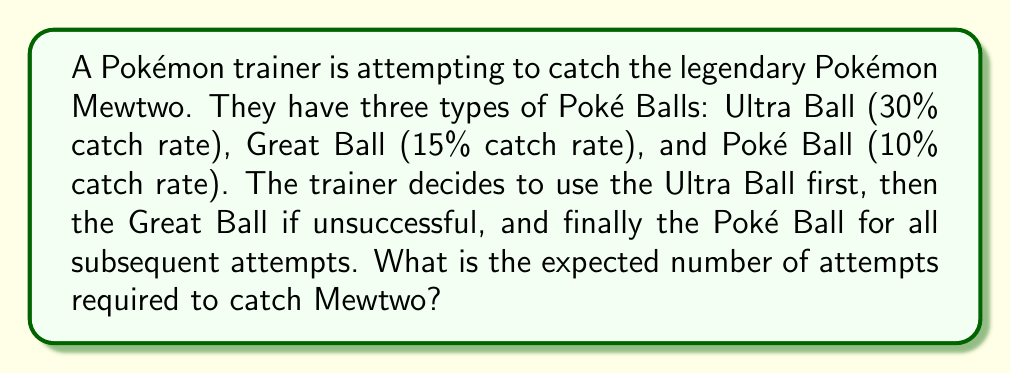Could you help me with this problem? Let's approach this step-by-step:

1) First, we need to calculate the probability of success on each attempt:
   - 1st attempt (Ultra Ball): $p_1 = 0.30$
   - 2nd attempt (Great Ball): $p_2 = 0.15$
   - 3rd and subsequent attempts (Poke Ball): $p_3 = 0.10$

2) The probability of needing exactly $k$ attempts is:
   For $k = 1$: $P(X = 1) = p_1 = 0.30$
   For $k = 2$: $P(X = 2) = (1-p_1)p_2 = 0.70 \times 0.15 = 0.105$
   For $k \geq 3$: $P(X = k) = (1-p_1)(1-p_2)(1-p_3)^{k-3}p_3$

3) The expected value is given by:
   $$E(X) = \sum_{k=1}^{\infty} k \cdot P(X = k)$$

4) Let's break this down:
   $$E(X) = 1 \cdot 0.30 + 2 \cdot 0.105 + \sum_{k=3}^{\infty} k \cdot (1-0.30)(1-0.15)(1-0.10)^{k-3} \cdot 0.10$$

5) The sum from $k=3$ to infinity is a geometric series. Let $q = 1-0.10 = 0.90$:
   $$\sum_{k=3}^{\infty} k \cdot 0.70 \cdot 0.85 \cdot q^{k-3} \cdot 0.10 = 0.5950 \cdot \sum_{k=3}^{\infty} k \cdot 0.90^{k-3}$$

6) The sum of this series can be calculated using the formula for the expected value of a geometric distribution:
   $$\sum_{k=3}^{\infty} k \cdot 0.90^{k-3} = \frac{3}{0.10} - \frac{2}{0.10} = 10$$

7) Putting it all together:
   $$E(X) = 0.30 + 0.210 + 0.5950 \cdot 10 = 6.460$$

Therefore, the expected number of attempts is approximately 6.460.
Answer: 6.460 attempts 